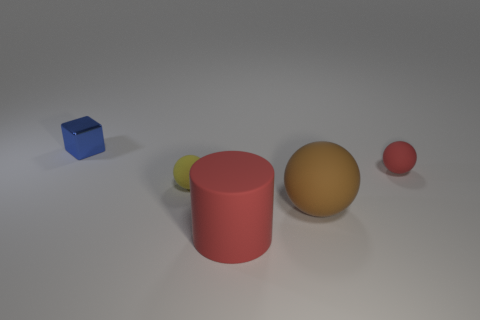Add 1 yellow things. How many objects exist? 6 Subtract all blocks. How many objects are left? 4 Add 2 small spheres. How many small spheres exist? 4 Subtract 1 red spheres. How many objects are left? 4 Subtract all big gray matte cubes. Subtract all small yellow rubber balls. How many objects are left? 4 Add 5 brown rubber objects. How many brown rubber objects are left? 6 